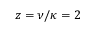Convert formula to latex. <formula><loc_0><loc_0><loc_500><loc_500>z = \nu / \kappa = 2</formula> 